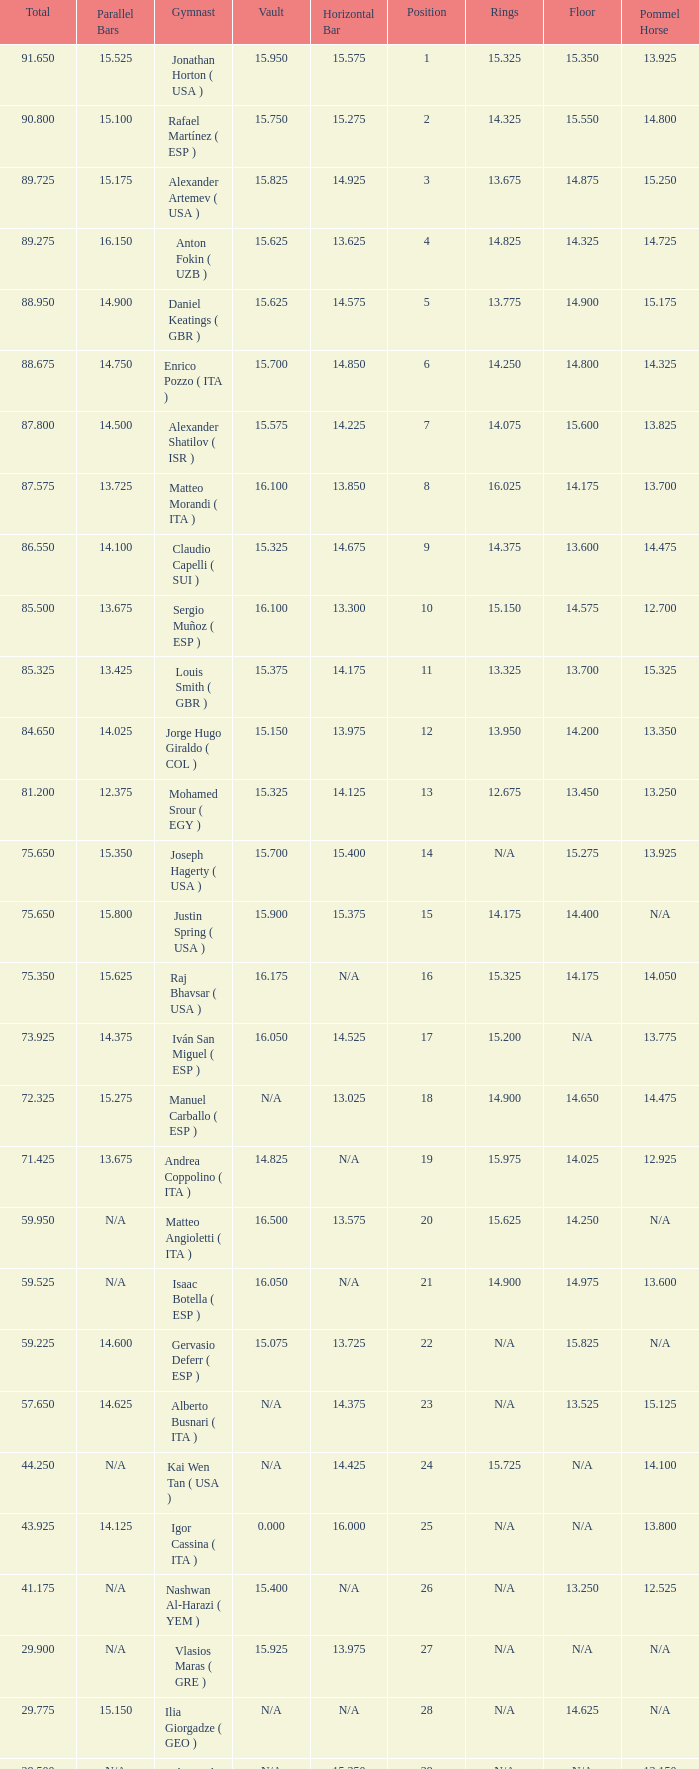If the floor number is 14.200, what is the number for the parallel bars? 14.025. 